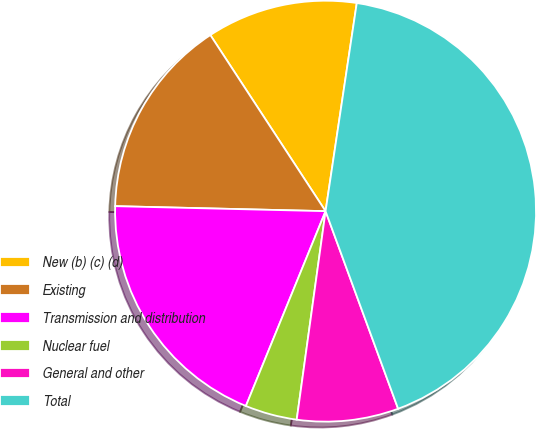Convert chart to OTSL. <chart><loc_0><loc_0><loc_500><loc_500><pie_chart><fcel>New (b) (c) (d)<fcel>Existing<fcel>Transmission and distribution<fcel>Nuclear fuel<fcel>General and other<fcel>Total<nl><fcel>11.59%<fcel>15.4%<fcel>19.2%<fcel>3.99%<fcel>7.79%<fcel>42.03%<nl></chart> 